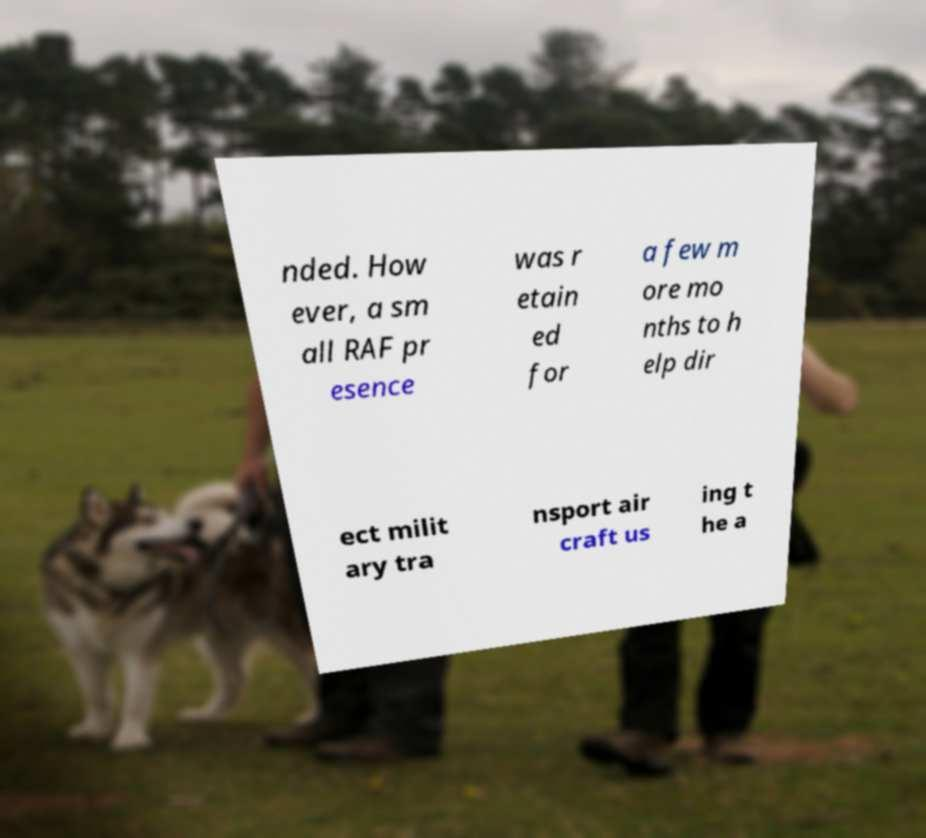Please read and relay the text visible in this image. What does it say? nded. How ever, a sm all RAF pr esence was r etain ed for a few m ore mo nths to h elp dir ect milit ary tra nsport air craft us ing t he a 